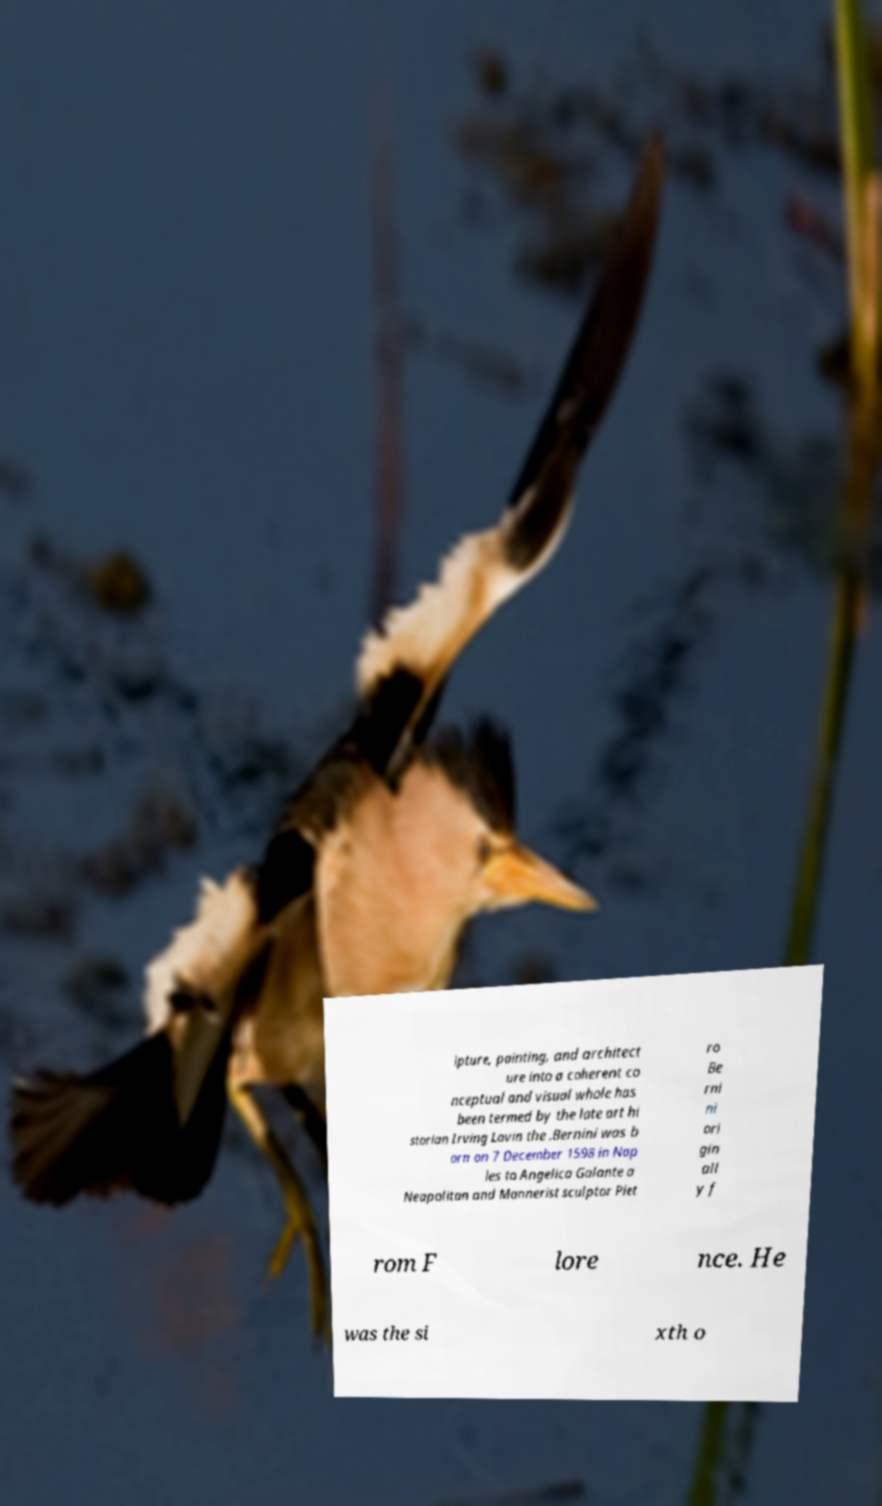Can you read and provide the text displayed in the image?This photo seems to have some interesting text. Can you extract and type it out for me? lpture, painting, and architect ure into a coherent co nceptual and visual whole has been termed by the late art hi storian Irving Lavin the .Bernini was b orn on 7 December 1598 in Nap les to Angelica Galante a Neapolitan and Mannerist sculptor Piet ro Be rni ni ori gin all y f rom F lore nce. He was the si xth o 